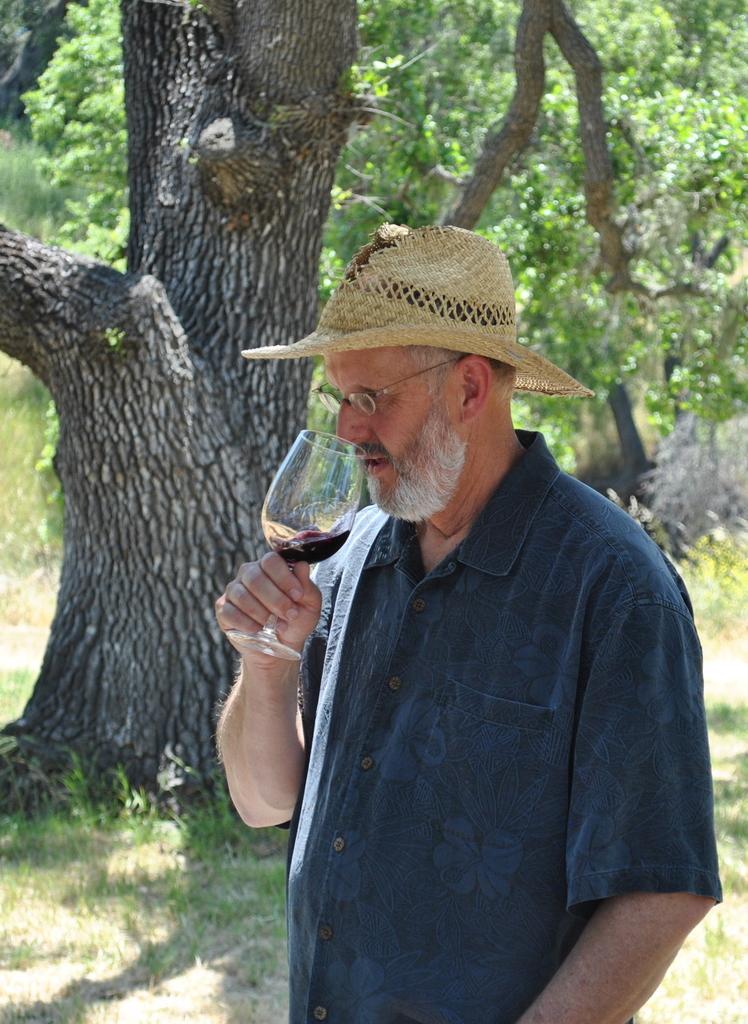In one or two sentences, can you explain what this image depicts? The person wearing blue shirt is drinking a glass of wine and there are trees in the background. 